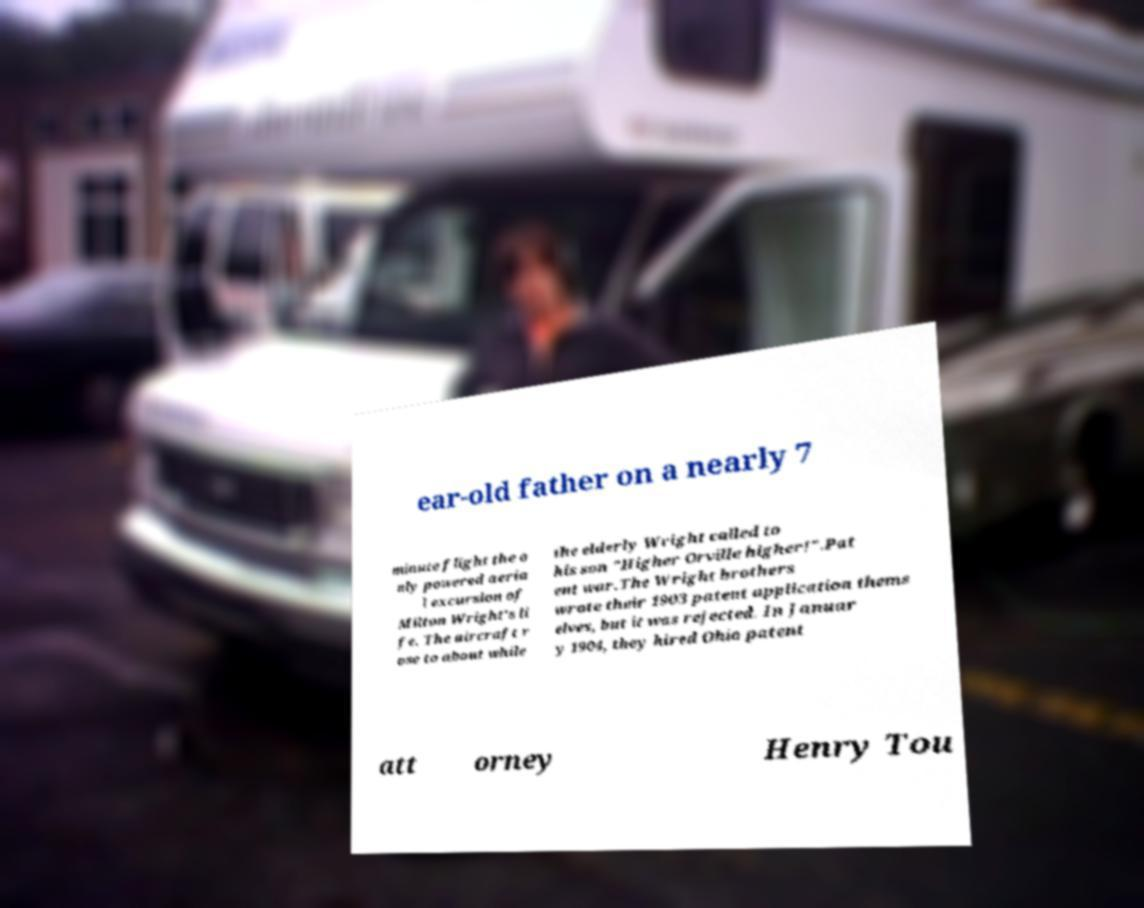Please identify and transcribe the text found in this image. ear-old father on a nearly 7 minute flight the o nly powered aeria l excursion of Milton Wright's li fe. The aircraft r ose to about while the elderly Wright called to his son "Higher Orville higher!".Pat ent war.The Wright brothers wrote their 1903 patent application thems elves, but it was rejected. In Januar y 1904, they hired Ohio patent att orney Henry Tou 